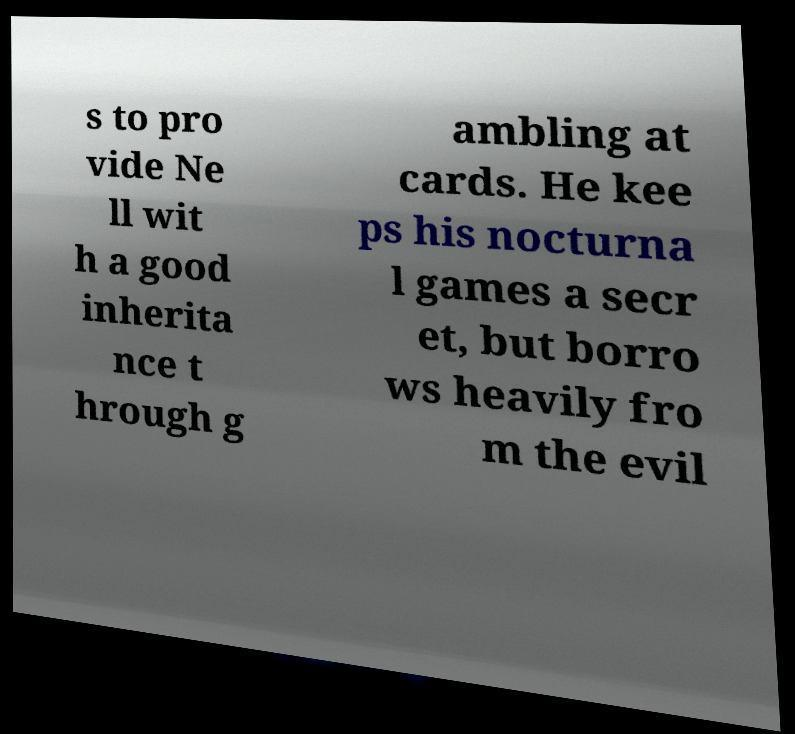I need the written content from this picture converted into text. Can you do that? s to pro vide Ne ll wit h a good inherita nce t hrough g ambling at cards. He kee ps his nocturna l games a secr et, but borro ws heavily fro m the evil 